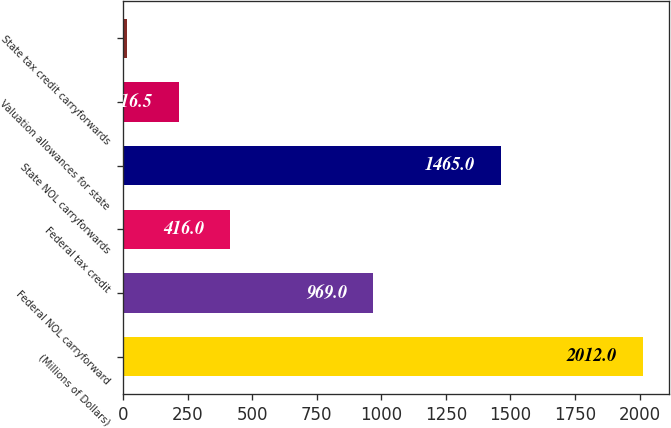<chart> <loc_0><loc_0><loc_500><loc_500><bar_chart><fcel>(Millions of Dollars)<fcel>Federal NOL carryforward<fcel>Federal tax credit<fcel>State NOL carryforwards<fcel>Valuation allowances for state<fcel>State tax credit carryforwards<nl><fcel>2012<fcel>969<fcel>416<fcel>1465<fcel>216.5<fcel>17<nl></chart> 